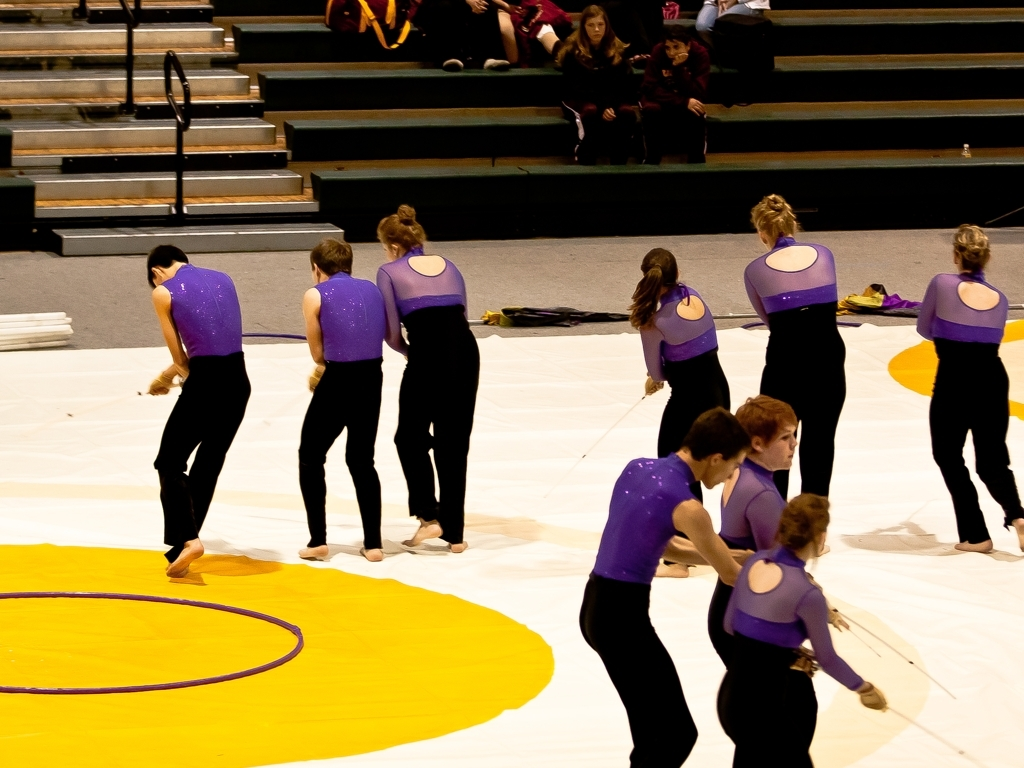Does the image lack clarity?
A. No
B. Yes
Answer with the option's letter from the given choices directly.
 A. 